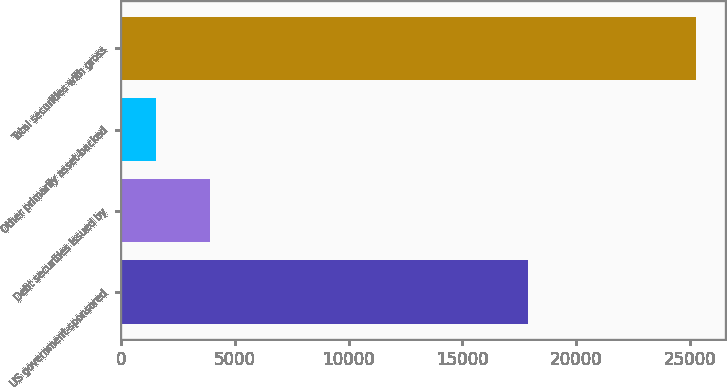Convert chart to OTSL. <chart><loc_0><loc_0><loc_500><loc_500><bar_chart><fcel>US government-sponsored<fcel>Debt securities issued by<fcel>Other primarily asset-backed<fcel>Total securities with gross<nl><fcel>17877<fcel>3925.8<fcel>1556<fcel>25254<nl></chart> 